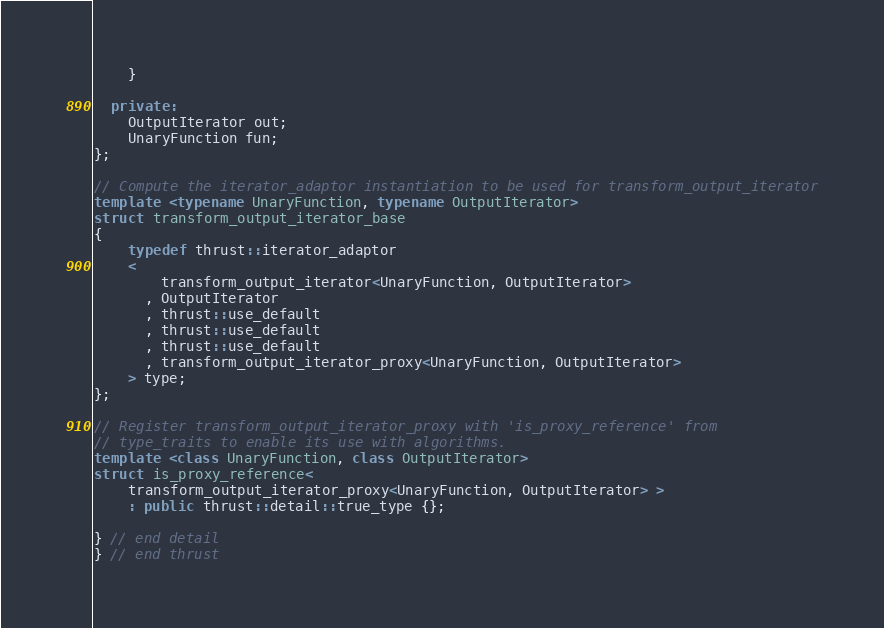<code> <loc_0><loc_0><loc_500><loc_500><_C++_>    }

  private:
    OutputIterator out;
    UnaryFunction fun;
};

// Compute the iterator_adaptor instantiation to be used for transform_output_iterator
template <typename UnaryFunction, typename OutputIterator>
struct transform_output_iterator_base
{
    typedef thrust::iterator_adaptor
    <
        transform_output_iterator<UnaryFunction, OutputIterator>
      , OutputIterator
      , thrust::use_default
      , thrust::use_default
      , thrust::use_default
      , transform_output_iterator_proxy<UnaryFunction, OutputIterator>
    > type;
};

// Register transform_output_iterator_proxy with 'is_proxy_reference' from
// type_traits to enable its use with algorithms.
template <class UnaryFunction, class OutputIterator>
struct is_proxy_reference<
    transform_output_iterator_proxy<UnaryFunction, OutputIterator> >
    : public thrust::detail::true_type {};

} // end detail
} // end thrust

</code> 